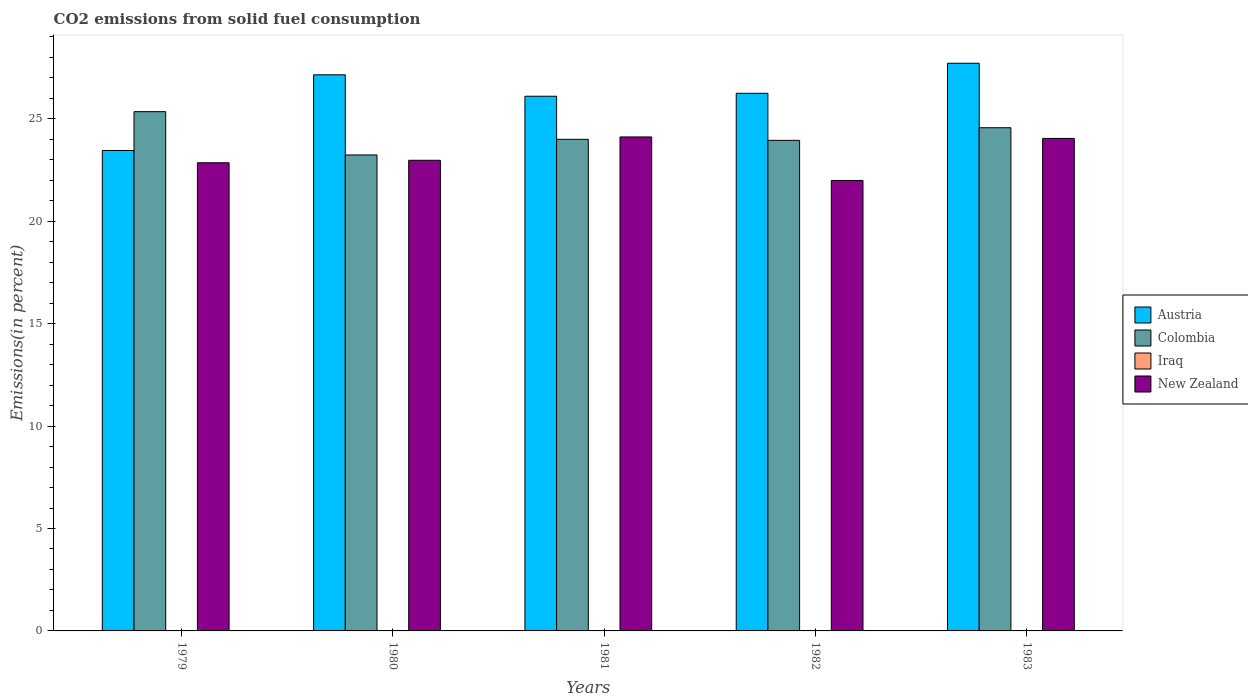What is the label of the 1st group of bars from the left?
Your answer should be compact. 1979. What is the total CO2 emitted in New Zealand in 1979?
Your answer should be compact. 22.86. Across all years, what is the maximum total CO2 emitted in Iraq?
Provide a succinct answer. 0.01. Across all years, what is the minimum total CO2 emitted in Iraq?
Your response must be concise. 0.01. In which year was the total CO2 emitted in Iraq maximum?
Make the answer very short. 1982. In which year was the total CO2 emitted in Austria minimum?
Your answer should be compact. 1979. What is the total total CO2 emitted in Colombia in the graph?
Provide a short and direct response. 121.11. What is the difference between the total CO2 emitted in New Zealand in 1979 and that in 1982?
Provide a succinct answer. 0.86. What is the difference between the total CO2 emitted in New Zealand in 1981 and the total CO2 emitted in Iraq in 1983?
Offer a very short reply. 24.11. What is the average total CO2 emitted in Austria per year?
Your response must be concise. 26.14. In the year 1981, what is the difference between the total CO2 emitted in New Zealand and total CO2 emitted in Colombia?
Your answer should be compact. 0.12. What is the ratio of the total CO2 emitted in Austria in 1980 to that in 1983?
Keep it short and to the point. 0.98. Is the total CO2 emitted in Colombia in 1980 less than that in 1981?
Offer a terse response. Yes. Is the difference between the total CO2 emitted in New Zealand in 1982 and 1983 greater than the difference between the total CO2 emitted in Colombia in 1982 and 1983?
Your answer should be compact. No. What is the difference between the highest and the second highest total CO2 emitted in New Zealand?
Provide a short and direct response. 0.07. What is the difference between the highest and the lowest total CO2 emitted in Austria?
Offer a terse response. 4.26. Is it the case that in every year, the sum of the total CO2 emitted in Iraq and total CO2 emitted in New Zealand is greater than the sum of total CO2 emitted in Austria and total CO2 emitted in Colombia?
Keep it short and to the point. No. What does the 1st bar from the left in 1980 represents?
Your answer should be very brief. Austria. Are the values on the major ticks of Y-axis written in scientific E-notation?
Keep it short and to the point. No. Does the graph contain grids?
Offer a very short reply. No. How are the legend labels stacked?
Provide a succinct answer. Vertical. What is the title of the graph?
Ensure brevity in your answer.  CO2 emissions from solid fuel consumption. Does "Guinea-Bissau" appear as one of the legend labels in the graph?
Your response must be concise. No. What is the label or title of the X-axis?
Your answer should be compact. Years. What is the label or title of the Y-axis?
Ensure brevity in your answer.  Emissions(in percent). What is the Emissions(in percent) of Austria in 1979?
Your answer should be compact. 23.46. What is the Emissions(in percent) of Colombia in 1979?
Provide a short and direct response. 25.35. What is the Emissions(in percent) of Iraq in 1979?
Ensure brevity in your answer.  0.01. What is the Emissions(in percent) of New Zealand in 1979?
Offer a very short reply. 22.86. What is the Emissions(in percent) in Austria in 1980?
Your answer should be very brief. 27.15. What is the Emissions(in percent) of Colombia in 1980?
Offer a terse response. 23.24. What is the Emissions(in percent) of Iraq in 1980?
Give a very brief answer. 0.01. What is the Emissions(in percent) in New Zealand in 1980?
Offer a terse response. 22.98. What is the Emissions(in percent) in Austria in 1981?
Your answer should be compact. 26.11. What is the Emissions(in percent) in Colombia in 1981?
Provide a succinct answer. 24. What is the Emissions(in percent) in Iraq in 1981?
Offer a very short reply. 0.01. What is the Emissions(in percent) of New Zealand in 1981?
Your answer should be compact. 24.12. What is the Emissions(in percent) in Austria in 1982?
Make the answer very short. 26.25. What is the Emissions(in percent) in Colombia in 1982?
Offer a terse response. 23.95. What is the Emissions(in percent) of Iraq in 1982?
Provide a short and direct response. 0.01. What is the Emissions(in percent) of New Zealand in 1982?
Provide a succinct answer. 21.99. What is the Emissions(in percent) in Austria in 1983?
Your answer should be very brief. 27.72. What is the Emissions(in percent) of Colombia in 1983?
Provide a succinct answer. 24.57. What is the Emissions(in percent) of Iraq in 1983?
Keep it short and to the point. 0.01. What is the Emissions(in percent) of New Zealand in 1983?
Make the answer very short. 24.05. Across all years, what is the maximum Emissions(in percent) in Austria?
Provide a succinct answer. 27.72. Across all years, what is the maximum Emissions(in percent) in Colombia?
Your answer should be compact. 25.35. Across all years, what is the maximum Emissions(in percent) in Iraq?
Offer a very short reply. 0.01. Across all years, what is the maximum Emissions(in percent) in New Zealand?
Offer a terse response. 24.12. Across all years, what is the minimum Emissions(in percent) of Austria?
Keep it short and to the point. 23.46. Across all years, what is the minimum Emissions(in percent) in Colombia?
Your answer should be very brief. 23.24. Across all years, what is the minimum Emissions(in percent) of Iraq?
Your response must be concise. 0.01. Across all years, what is the minimum Emissions(in percent) in New Zealand?
Your answer should be compact. 21.99. What is the total Emissions(in percent) of Austria in the graph?
Provide a succinct answer. 130.68. What is the total Emissions(in percent) in Colombia in the graph?
Ensure brevity in your answer.  121.11. What is the total Emissions(in percent) in Iraq in the graph?
Your answer should be very brief. 0.05. What is the total Emissions(in percent) in New Zealand in the graph?
Your response must be concise. 115.99. What is the difference between the Emissions(in percent) in Austria in 1979 and that in 1980?
Your answer should be very brief. -3.7. What is the difference between the Emissions(in percent) of Colombia in 1979 and that in 1980?
Offer a terse response. 2.11. What is the difference between the Emissions(in percent) in Iraq in 1979 and that in 1980?
Your answer should be very brief. -0. What is the difference between the Emissions(in percent) in New Zealand in 1979 and that in 1980?
Your answer should be compact. -0.12. What is the difference between the Emissions(in percent) in Austria in 1979 and that in 1981?
Provide a succinct answer. -2.65. What is the difference between the Emissions(in percent) in Colombia in 1979 and that in 1981?
Give a very brief answer. 1.35. What is the difference between the Emissions(in percent) of Iraq in 1979 and that in 1981?
Keep it short and to the point. -0. What is the difference between the Emissions(in percent) of New Zealand in 1979 and that in 1981?
Provide a succinct answer. -1.26. What is the difference between the Emissions(in percent) in Austria in 1979 and that in 1982?
Your response must be concise. -2.79. What is the difference between the Emissions(in percent) in Colombia in 1979 and that in 1982?
Keep it short and to the point. 1.4. What is the difference between the Emissions(in percent) in Iraq in 1979 and that in 1982?
Offer a very short reply. -0.01. What is the difference between the Emissions(in percent) of New Zealand in 1979 and that in 1982?
Keep it short and to the point. 0.86. What is the difference between the Emissions(in percent) in Austria in 1979 and that in 1983?
Offer a very short reply. -4.26. What is the difference between the Emissions(in percent) of Colombia in 1979 and that in 1983?
Keep it short and to the point. 0.78. What is the difference between the Emissions(in percent) of Iraq in 1979 and that in 1983?
Give a very brief answer. -0. What is the difference between the Emissions(in percent) of New Zealand in 1979 and that in 1983?
Offer a terse response. -1.19. What is the difference between the Emissions(in percent) of Austria in 1980 and that in 1981?
Provide a succinct answer. 1.05. What is the difference between the Emissions(in percent) in Colombia in 1980 and that in 1981?
Your response must be concise. -0.76. What is the difference between the Emissions(in percent) of Iraq in 1980 and that in 1981?
Provide a succinct answer. -0. What is the difference between the Emissions(in percent) of New Zealand in 1980 and that in 1981?
Provide a succinct answer. -1.14. What is the difference between the Emissions(in percent) in Austria in 1980 and that in 1982?
Offer a terse response. 0.9. What is the difference between the Emissions(in percent) of Colombia in 1980 and that in 1982?
Your answer should be very brief. -0.71. What is the difference between the Emissions(in percent) of Iraq in 1980 and that in 1982?
Make the answer very short. -0. What is the difference between the Emissions(in percent) in New Zealand in 1980 and that in 1982?
Offer a very short reply. 0.98. What is the difference between the Emissions(in percent) of Austria in 1980 and that in 1983?
Provide a short and direct response. -0.56. What is the difference between the Emissions(in percent) in Colombia in 1980 and that in 1983?
Offer a very short reply. -1.33. What is the difference between the Emissions(in percent) of Iraq in 1980 and that in 1983?
Give a very brief answer. -0. What is the difference between the Emissions(in percent) in New Zealand in 1980 and that in 1983?
Offer a terse response. -1.07. What is the difference between the Emissions(in percent) in Austria in 1981 and that in 1982?
Your answer should be compact. -0.14. What is the difference between the Emissions(in percent) of Colombia in 1981 and that in 1982?
Your answer should be very brief. 0.05. What is the difference between the Emissions(in percent) of Iraq in 1981 and that in 1982?
Your answer should be compact. -0. What is the difference between the Emissions(in percent) of New Zealand in 1981 and that in 1982?
Your answer should be compact. 2.12. What is the difference between the Emissions(in percent) in Austria in 1981 and that in 1983?
Your response must be concise. -1.61. What is the difference between the Emissions(in percent) in Colombia in 1981 and that in 1983?
Keep it short and to the point. -0.57. What is the difference between the Emissions(in percent) in Iraq in 1981 and that in 1983?
Ensure brevity in your answer.  0. What is the difference between the Emissions(in percent) of New Zealand in 1981 and that in 1983?
Offer a very short reply. 0.07. What is the difference between the Emissions(in percent) in Austria in 1982 and that in 1983?
Your answer should be compact. -1.47. What is the difference between the Emissions(in percent) in Colombia in 1982 and that in 1983?
Provide a short and direct response. -0.62. What is the difference between the Emissions(in percent) of Iraq in 1982 and that in 1983?
Offer a terse response. 0. What is the difference between the Emissions(in percent) in New Zealand in 1982 and that in 1983?
Keep it short and to the point. -2.05. What is the difference between the Emissions(in percent) of Austria in 1979 and the Emissions(in percent) of Colombia in 1980?
Make the answer very short. 0.22. What is the difference between the Emissions(in percent) of Austria in 1979 and the Emissions(in percent) of Iraq in 1980?
Your answer should be compact. 23.45. What is the difference between the Emissions(in percent) in Austria in 1979 and the Emissions(in percent) in New Zealand in 1980?
Your answer should be compact. 0.48. What is the difference between the Emissions(in percent) of Colombia in 1979 and the Emissions(in percent) of Iraq in 1980?
Offer a very short reply. 25.34. What is the difference between the Emissions(in percent) in Colombia in 1979 and the Emissions(in percent) in New Zealand in 1980?
Your response must be concise. 2.37. What is the difference between the Emissions(in percent) in Iraq in 1979 and the Emissions(in percent) in New Zealand in 1980?
Offer a very short reply. -22.97. What is the difference between the Emissions(in percent) of Austria in 1979 and the Emissions(in percent) of Colombia in 1981?
Keep it short and to the point. -0.55. What is the difference between the Emissions(in percent) in Austria in 1979 and the Emissions(in percent) in Iraq in 1981?
Give a very brief answer. 23.45. What is the difference between the Emissions(in percent) of Austria in 1979 and the Emissions(in percent) of New Zealand in 1981?
Provide a succinct answer. -0.66. What is the difference between the Emissions(in percent) of Colombia in 1979 and the Emissions(in percent) of Iraq in 1981?
Your answer should be very brief. 25.34. What is the difference between the Emissions(in percent) in Colombia in 1979 and the Emissions(in percent) in New Zealand in 1981?
Provide a short and direct response. 1.23. What is the difference between the Emissions(in percent) in Iraq in 1979 and the Emissions(in percent) in New Zealand in 1981?
Ensure brevity in your answer.  -24.11. What is the difference between the Emissions(in percent) in Austria in 1979 and the Emissions(in percent) in Colombia in 1982?
Ensure brevity in your answer.  -0.5. What is the difference between the Emissions(in percent) of Austria in 1979 and the Emissions(in percent) of Iraq in 1982?
Make the answer very short. 23.44. What is the difference between the Emissions(in percent) in Austria in 1979 and the Emissions(in percent) in New Zealand in 1982?
Your answer should be very brief. 1.46. What is the difference between the Emissions(in percent) in Colombia in 1979 and the Emissions(in percent) in Iraq in 1982?
Your response must be concise. 25.34. What is the difference between the Emissions(in percent) in Colombia in 1979 and the Emissions(in percent) in New Zealand in 1982?
Offer a very short reply. 3.36. What is the difference between the Emissions(in percent) of Iraq in 1979 and the Emissions(in percent) of New Zealand in 1982?
Your answer should be compact. -21.99. What is the difference between the Emissions(in percent) in Austria in 1979 and the Emissions(in percent) in Colombia in 1983?
Your answer should be compact. -1.11. What is the difference between the Emissions(in percent) of Austria in 1979 and the Emissions(in percent) of Iraq in 1983?
Your answer should be compact. 23.45. What is the difference between the Emissions(in percent) of Austria in 1979 and the Emissions(in percent) of New Zealand in 1983?
Ensure brevity in your answer.  -0.59. What is the difference between the Emissions(in percent) of Colombia in 1979 and the Emissions(in percent) of Iraq in 1983?
Keep it short and to the point. 25.34. What is the difference between the Emissions(in percent) of Colombia in 1979 and the Emissions(in percent) of New Zealand in 1983?
Provide a short and direct response. 1.31. What is the difference between the Emissions(in percent) in Iraq in 1979 and the Emissions(in percent) in New Zealand in 1983?
Offer a terse response. -24.04. What is the difference between the Emissions(in percent) of Austria in 1980 and the Emissions(in percent) of Colombia in 1981?
Provide a succinct answer. 3.15. What is the difference between the Emissions(in percent) of Austria in 1980 and the Emissions(in percent) of Iraq in 1981?
Ensure brevity in your answer.  27.14. What is the difference between the Emissions(in percent) of Austria in 1980 and the Emissions(in percent) of New Zealand in 1981?
Keep it short and to the point. 3.03. What is the difference between the Emissions(in percent) in Colombia in 1980 and the Emissions(in percent) in Iraq in 1981?
Your answer should be compact. 23.23. What is the difference between the Emissions(in percent) in Colombia in 1980 and the Emissions(in percent) in New Zealand in 1981?
Provide a short and direct response. -0.88. What is the difference between the Emissions(in percent) in Iraq in 1980 and the Emissions(in percent) in New Zealand in 1981?
Your answer should be very brief. -24.11. What is the difference between the Emissions(in percent) in Austria in 1980 and the Emissions(in percent) in Colombia in 1982?
Offer a very short reply. 3.2. What is the difference between the Emissions(in percent) of Austria in 1980 and the Emissions(in percent) of Iraq in 1982?
Ensure brevity in your answer.  27.14. What is the difference between the Emissions(in percent) in Austria in 1980 and the Emissions(in percent) in New Zealand in 1982?
Provide a succinct answer. 5.16. What is the difference between the Emissions(in percent) of Colombia in 1980 and the Emissions(in percent) of Iraq in 1982?
Provide a short and direct response. 23.23. What is the difference between the Emissions(in percent) in Colombia in 1980 and the Emissions(in percent) in New Zealand in 1982?
Offer a terse response. 1.24. What is the difference between the Emissions(in percent) of Iraq in 1980 and the Emissions(in percent) of New Zealand in 1982?
Provide a short and direct response. -21.99. What is the difference between the Emissions(in percent) of Austria in 1980 and the Emissions(in percent) of Colombia in 1983?
Give a very brief answer. 2.58. What is the difference between the Emissions(in percent) in Austria in 1980 and the Emissions(in percent) in Iraq in 1983?
Your answer should be compact. 27.14. What is the difference between the Emissions(in percent) of Austria in 1980 and the Emissions(in percent) of New Zealand in 1983?
Keep it short and to the point. 3.11. What is the difference between the Emissions(in percent) in Colombia in 1980 and the Emissions(in percent) in Iraq in 1983?
Your response must be concise. 23.23. What is the difference between the Emissions(in percent) in Colombia in 1980 and the Emissions(in percent) in New Zealand in 1983?
Offer a terse response. -0.81. What is the difference between the Emissions(in percent) in Iraq in 1980 and the Emissions(in percent) in New Zealand in 1983?
Your answer should be compact. -24.04. What is the difference between the Emissions(in percent) of Austria in 1981 and the Emissions(in percent) of Colombia in 1982?
Provide a short and direct response. 2.15. What is the difference between the Emissions(in percent) of Austria in 1981 and the Emissions(in percent) of Iraq in 1982?
Your answer should be very brief. 26.09. What is the difference between the Emissions(in percent) of Austria in 1981 and the Emissions(in percent) of New Zealand in 1982?
Your answer should be very brief. 4.11. What is the difference between the Emissions(in percent) of Colombia in 1981 and the Emissions(in percent) of Iraq in 1982?
Offer a terse response. 23.99. What is the difference between the Emissions(in percent) of Colombia in 1981 and the Emissions(in percent) of New Zealand in 1982?
Give a very brief answer. 2.01. What is the difference between the Emissions(in percent) of Iraq in 1981 and the Emissions(in percent) of New Zealand in 1982?
Your response must be concise. -21.98. What is the difference between the Emissions(in percent) in Austria in 1981 and the Emissions(in percent) in Colombia in 1983?
Your answer should be compact. 1.54. What is the difference between the Emissions(in percent) in Austria in 1981 and the Emissions(in percent) in Iraq in 1983?
Your answer should be very brief. 26.1. What is the difference between the Emissions(in percent) of Austria in 1981 and the Emissions(in percent) of New Zealand in 1983?
Make the answer very short. 2.06. What is the difference between the Emissions(in percent) of Colombia in 1981 and the Emissions(in percent) of Iraq in 1983?
Ensure brevity in your answer.  23.99. What is the difference between the Emissions(in percent) of Colombia in 1981 and the Emissions(in percent) of New Zealand in 1983?
Make the answer very short. -0.04. What is the difference between the Emissions(in percent) of Iraq in 1981 and the Emissions(in percent) of New Zealand in 1983?
Offer a terse response. -24.03. What is the difference between the Emissions(in percent) of Austria in 1982 and the Emissions(in percent) of Colombia in 1983?
Make the answer very short. 1.68. What is the difference between the Emissions(in percent) in Austria in 1982 and the Emissions(in percent) in Iraq in 1983?
Make the answer very short. 26.24. What is the difference between the Emissions(in percent) in Austria in 1982 and the Emissions(in percent) in New Zealand in 1983?
Provide a succinct answer. 2.2. What is the difference between the Emissions(in percent) of Colombia in 1982 and the Emissions(in percent) of Iraq in 1983?
Offer a terse response. 23.94. What is the difference between the Emissions(in percent) of Colombia in 1982 and the Emissions(in percent) of New Zealand in 1983?
Give a very brief answer. -0.09. What is the difference between the Emissions(in percent) of Iraq in 1982 and the Emissions(in percent) of New Zealand in 1983?
Give a very brief answer. -24.03. What is the average Emissions(in percent) in Austria per year?
Your answer should be very brief. 26.14. What is the average Emissions(in percent) in Colombia per year?
Your answer should be very brief. 24.22. What is the average Emissions(in percent) of Iraq per year?
Ensure brevity in your answer.  0.01. What is the average Emissions(in percent) in New Zealand per year?
Make the answer very short. 23.2. In the year 1979, what is the difference between the Emissions(in percent) in Austria and Emissions(in percent) in Colombia?
Your answer should be very brief. -1.9. In the year 1979, what is the difference between the Emissions(in percent) in Austria and Emissions(in percent) in Iraq?
Ensure brevity in your answer.  23.45. In the year 1979, what is the difference between the Emissions(in percent) in Austria and Emissions(in percent) in New Zealand?
Provide a short and direct response. 0.6. In the year 1979, what is the difference between the Emissions(in percent) of Colombia and Emissions(in percent) of Iraq?
Offer a terse response. 25.35. In the year 1979, what is the difference between the Emissions(in percent) of Colombia and Emissions(in percent) of New Zealand?
Your answer should be compact. 2.5. In the year 1979, what is the difference between the Emissions(in percent) in Iraq and Emissions(in percent) in New Zealand?
Your response must be concise. -22.85. In the year 1980, what is the difference between the Emissions(in percent) in Austria and Emissions(in percent) in Colombia?
Offer a terse response. 3.91. In the year 1980, what is the difference between the Emissions(in percent) of Austria and Emissions(in percent) of Iraq?
Your response must be concise. 27.14. In the year 1980, what is the difference between the Emissions(in percent) of Austria and Emissions(in percent) of New Zealand?
Provide a succinct answer. 4.17. In the year 1980, what is the difference between the Emissions(in percent) of Colombia and Emissions(in percent) of Iraq?
Offer a very short reply. 23.23. In the year 1980, what is the difference between the Emissions(in percent) in Colombia and Emissions(in percent) in New Zealand?
Ensure brevity in your answer.  0.26. In the year 1980, what is the difference between the Emissions(in percent) of Iraq and Emissions(in percent) of New Zealand?
Offer a very short reply. -22.97. In the year 1981, what is the difference between the Emissions(in percent) of Austria and Emissions(in percent) of Colombia?
Make the answer very short. 2.1. In the year 1981, what is the difference between the Emissions(in percent) in Austria and Emissions(in percent) in Iraq?
Offer a terse response. 26.09. In the year 1981, what is the difference between the Emissions(in percent) in Austria and Emissions(in percent) in New Zealand?
Ensure brevity in your answer.  1.99. In the year 1981, what is the difference between the Emissions(in percent) in Colombia and Emissions(in percent) in Iraq?
Make the answer very short. 23.99. In the year 1981, what is the difference between the Emissions(in percent) of Colombia and Emissions(in percent) of New Zealand?
Keep it short and to the point. -0.12. In the year 1981, what is the difference between the Emissions(in percent) of Iraq and Emissions(in percent) of New Zealand?
Ensure brevity in your answer.  -24.11. In the year 1982, what is the difference between the Emissions(in percent) of Austria and Emissions(in percent) of Colombia?
Make the answer very short. 2.3. In the year 1982, what is the difference between the Emissions(in percent) in Austria and Emissions(in percent) in Iraq?
Your answer should be very brief. 26.24. In the year 1982, what is the difference between the Emissions(in percent) of Austria and Emissions(in percent) of New Zealand?
Your answer should be very brief. 4.25. In the year 1982, what is the difference between the Emissions(in percent) of Colombia and Emissions(in percent) of Iraq?
Your answer should be very brief. 23.94. In the year 1982, what is the difference between the Emissions(in percent) of Colombia and Emissions(in percent) of New Zealand?
Make the answer very short. 1.96. In the year 1982, what is the difference between the Emissions(in percent) of Iraq and Emissions(in percent) of New Zealand?
Give a very brief answer. -21.98. In the year 1983, what is the difference between the Emissions(in percent) in Austria and Emissions(in percent) in Colombia?
Make the answer very short. 3.15. In the year 1983, what is the difference between the Emissions(in percent) of Austria and Emissions(in percent) of Iraq?
Your answer should be compact. 27.71. In the year 1983, what is the difference between the Emissions(in percent) in Austria and Emissions(in percent) in New Zealand?
Make the answer very short. 3.67. In the year 1983, what is the difference between the Emissions(in percent) of Colombia and Emissions(in percent) of Iraq?
Give a very brief answer. 24.56. In the year 1983, what is the difference between the Emissions(in percent) of Colombia and Emissions(in percent) of New Zealand?
Provide a succinct answer. 0.52. In the year 1983, what is the difference between the Emissions(in percent) in Iraq and Emissions(in percent) in New Zealand?
Your answer should be very brief. -24.04. What is the ratio of the Emissions(in percent) of Austria in 1979 to that in 1980?
Provide a succinct answer. 0.86. What is the ratio of the Emissions(in percent) in Colombia in 1979 to that in 1980?
Your answer should be compact. 1.09. What is the ratio of the Emissions(in percent) of Iraq in 1979 to that in 1980?
Make the answer very short. 0.86. What is the ratio of the Emissions(in percent) of Austria in 1979 to that in 1981?
Your answer should be compact. 0.9. What is the ratio of the Emissions(in percent) in Colombia in 1979 to that in 1981?
Give a very brief answer. 1.06. What is the ratio of the Emissions(in percent) in Iraq in 1979 to that in 1981?
Provide a short and direct response. 0.61. What is the ratio of the Emissions(in percent) of New Zealand in 1979 to that in 1981?
Give a very brief answer. 0.95. What is the ratio of the Emissions(in percent) in Austria in 1979 to that in 1982?
Make the answer very short. 0.89. What is the ratio of the Emissions(in percent) in Colombia in 1979 to that in 1982?
Offer a very short reply. 1.06. What is the ratio of the Emissions(in percent) in Iraq in 1979 to that in 1982?
Ensure brevity in your answer.  0.58. What is the ratio of the Emissions(in percent) in New Zealand in 1979 to that in 1982?
Ensure brevity in your answer.  1.04. What is the ratio of the Emissions(in percent) of Austria in 1979 to that in 1983?
Make the answer very short. 0.85. What is the ratio of the Emissions(in percent) in Colombia in 1979 to that in 1983?
Your response must be concise. 1.03. What is the ratio of the Emissions(in percent) of Iraq in 1979 to that in 1983?
Provide a short and direct response. 0.73. What is the ratio of the Emissions(in percent) of New Zealand in 1979 to that in 1983?
Offer a terse response. 0.95. What is the ratio of the Emissions(in percent) in Austria in 1980 to that in 1981?
Your answer should be very brief. 1.04. What is the ratio of the Emissions(in percent) in Colombia in 1980 to that in 1981?
Offer a terse response. 0.97. What is the ratio of the Emissions(in percent) in Iraq in 1980 to that in 1981?
Offer a very short reply. 0.71. What is the ratio of the Emissions(in percent) in New Zealand in 1980 to that in 1981?
Make the answer very short. 0.95. What is the ratio of the Emissions(in percent) in Austria in 1980 to that in 1982?
Your response must be concise. 1.03. What is the ratio of the Emissions(in percent) of Colombia in 1980 to that in 1982?
Give a very brief answer. 0.97. What is the ratio of the Emissions(in percent) of Iraq in 1980 to that in 1982?
Ensure brevity in your answer.  0.67. What is the ratio of the Emissions(in percent) in New Zealand in 1980 to that in 1982?
Provide a short and direct response. 1.04. What is the ratio of the Emissions(in percent) of Austria in 1980 to that in 1983?
Your answer should be compact. 0.98. What is the ratio of the Emissions(in percent) in Colombia in 1980 to that in 1983?
Give a very brief answer. 0.95. What is the ratio of the Emissions(in percent) in Iraq in 1980 to that in 1983?
Your answer should be very brief. 0.85. What is the ratio of the Emissions(in percent) of New Zealand in 1980 to that in 1983?
Give a very brief answer. 0.96. What is the ratio of the Emissions(in percent) in Colombia in 1981 to that in 1982?
Ensure brevity in your answer.  1. What is the ratio of the Emissions(in percent) in Iraq in 1981 to that in 1982?
Your answer should be compact. 0.95. What is the ratio of the Emissions(in percent) of New Zealand in 1981 to that in 1982?
Your response must be concise. 1.1. What is the ratio of the Emissions(in percent) of Austria in 1981 to that in 1983?
Provide a succinct answer. 0.94. What is the ratio of the Emissions(in percent) in Colombia in 1981 to that in 1983?
Offer a very short reply. 0.98. What is the ratio of the Emissions(in percent) of Iraq in 1981 to that in 1983?
Provide a succinct answer. 1.21. What is the ratio of the Emissions(in percent) of New Zealand in 1981 to that in 1983?
Your answer should be compact. 1. What is the ratio of the Emissions(in percent) of Austria in 1982 to that in 1983?
Make the answer very short. 0.95. What is the ratio of the Emissions(in percent) of Colombia in 1982 to that in 1983?
Your response must be concise. 0.97. What is the ratio of the Emissions(in percent) of Iraq in 1982 to that in 1983?
Give a very brief answer. 1.27. What is the ratio of the Emissions(in percent) of New Zealand in 1982 to that in 1983?
Your answer should be compact. 0.91. What is the difference between the highest and the second highest Emissions(in percent) of Austria?
Ensure brevity in your answer.  0.56. What is the difference between the highest and the second highest Emissions(in percent) in Colombia?
Offer a very short reply. 0.78. What is the difference between the highest and the second highest Emissions(in percent) of Iraq?
Provide a succinct answer. 0. What is the difference between the highest and the second highest Emissions(in percent) of New Zealand?
Your answer should be very brief. 0.07. What is the difference between the highest and the lowest Emissions(in percent) of Austria?
Ensure brevity in your answer.  4.26. What is the difference between the highest and the lowest Emissions(in percent) of Colombia?
Provide a succinct answer. 2.11. What is the difference between the highest and the lowest Emissions(in percent) of Iraq?
Offer a terse response. 0.01. What is the difference between the highest and the lowest Emissions(in percent) in New Zealand?
Your response must be concise. 2.12. 